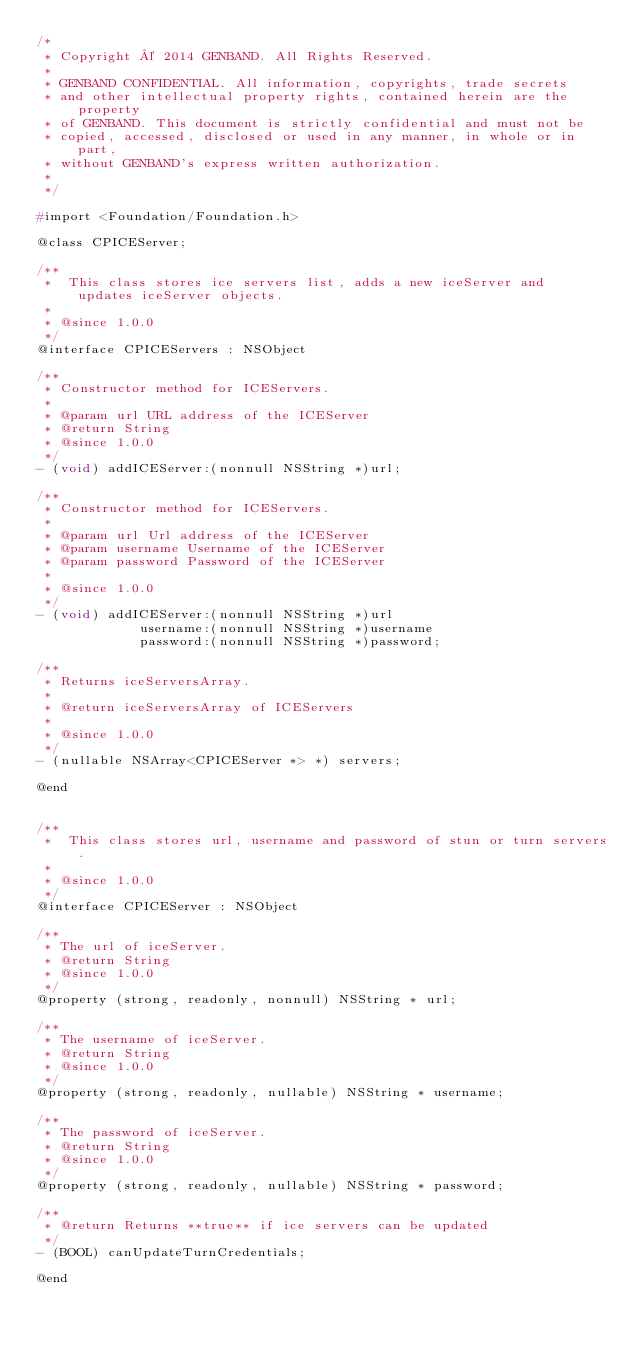Convert code to text. <code><loc_0><loc_0><loc_500><loc_500><_C_>/*
 * Copyright © 2014 GENBAND. All Rights Reserved.
 *
 * GENBAND CONFIDENTIAL. All information, copyrights, trade secrets
 * and other intellectual property rights, contained herein are the property
 * of GENBAND. This document is strictly confidential and must not be
 * copied, accessed, disclosed or used in any manner, in whole or in part,
 * without GENBAND's express written authorization.
 *
 */

#import <Foundation/Foundation.h>

@class CPICEServer;

/**
 *  This class stores ice servers list, adds a new iceServer and  updates iceServer objects.
 *
 * @since 1.0.0
 */
@interface CPICEServers : NSObject

/**
 * Constructor method for ICEServers.
 *
 * @param url URL address of the ICEServer
 * @return String
 * @since 1.0.0
 */
- (void) addICEServer:(nonnull NSString *)url;

/**
 * Constructor method for ICEServers.
 *
 * @param url Url address of the ICEServer
 * @param username Username of the ICEServer
 * @param password Password of the ICEServer
 *
 * @since 1.0.0
 */
- (void) addICEServer:(nonnull NSString *)url
             username:(nonnull NSString *)username
             password:(nonnull NSString *)password;

/**
 * Returns iceServersArray.
 *
 * @return iceServersArray of ICEServers
 *
 * @since 1.0.0
 */
- (nullable NSArray<CPICEServer *> *) servers;

@end


/**
 *  This class stores url, username and password of stun or turn servers.
 *
 * @since 1.0.0
 */
@interface CPICEServer : NSObject

/**
 * The url of iceServer.
 * @return String
 * @since 1.0.0
 */
@property (strong, readonly, nonnull) NSString * url;

/**
 * The username of iceServer.
 * @return String
 * @since 1.0.0
 */
@property (strong, readonly, nullable) NSString * username;

/**
 * The password of iceServer.
 * @return String
 * @since 1.0.0
 */
@property (strong, readonly, nullable) NSString * password;

/**
 * @return Returns **true** if ice servers can be updated
 */
- (BOOL) canUpdateTurnCredentials;

@end
</code> 